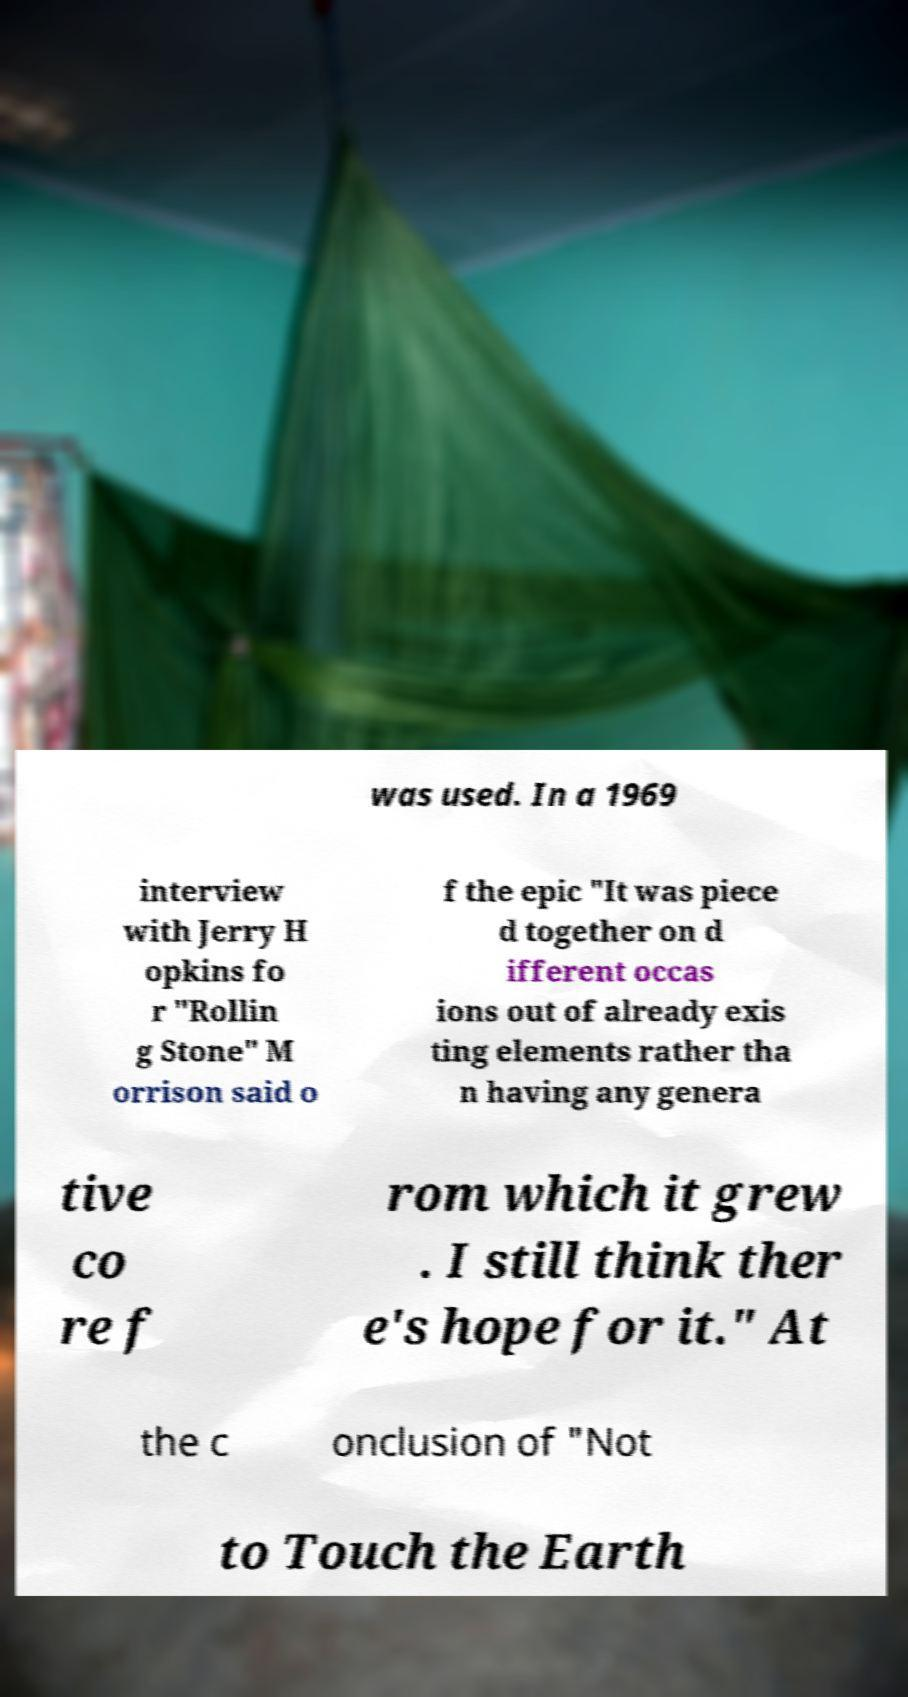What messages or text are displayed in this image? I need them in a readable, typed format. was used. In a 1969 interview with Jerry H opkins fo r "Rollin g Stone" M orrison said o f the epic "It was piece d together on d ifferent occas ions out of already exis ting elements rather tha n having any genera tive co re f rom which it grew . I still think ther e's hope for it." At the c onclusion of "Not to Touch the Earth 